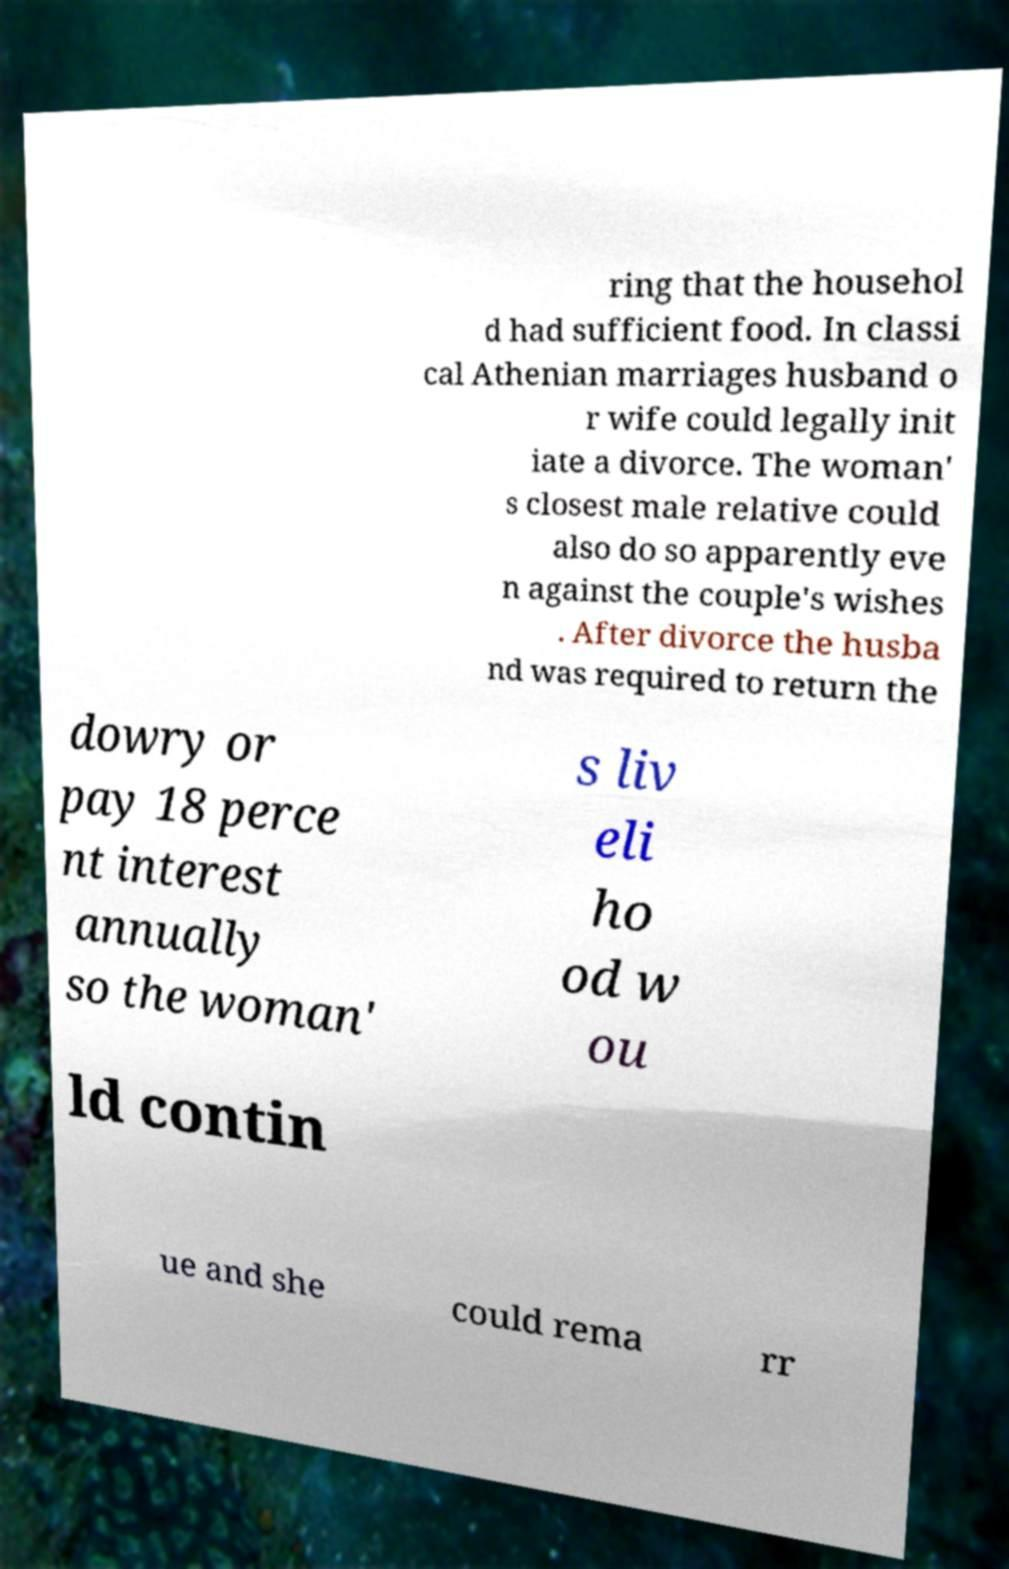Please identify and transcribe the text found in this image. ring that the househol d had sufficient food. In classi cal Athenian marriages husband o r wife could legally init iate a divorce. The woman' s closest male relative could also do so apparently eve n against the couple's wishes . After divorce the husba nd was required to return the dowry or pay 18 perce nt interest annually so the woman' s liv eli ho od w ou ld contin ue and she could rema rr 